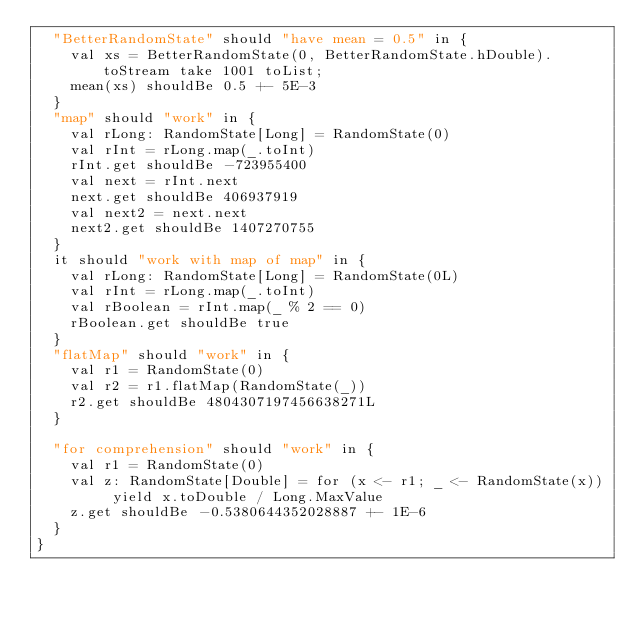Convert code to text. <code><loc_0><loc_0><loc_500><loc_500><_Scala_>  "BetterRandomState" should "have mean = 0.5" in {
    val xs = BetterRandomState(0, BetterRandomState.hDouble).toStream take 1001 toList;
    mean(xs) shouldBe 0.5 +- 5E-3
  }
  "map" should "work" in {
    val rLong: RandomState[Long] = RandomState(0)
    val rInt = rLong.map(_.toInt)
    rInt.get shouldBe -723955400
    val next = rInt.next
    next.get shouldBe 406937919
    val next2 = next.next
    next2.get shouldBe 1407270755
  }
  it should "work with map of map" in {
    val rLong: RandomState[Long] = RandomState(0L)
    val rInt = rLong.map(_.toInt)
    val rBoolean = rInt.map(_ % 2 == 0)
    rBoolean.get shouldBe true
  }
  "flatMap" should "work" in {
    val r1 = RandomState(0)
    val r2 = r1.flatMap(RandomState(_))
    r2.get shouldBe 4804307197456638271L
  }

  "for comprehension" should "work" in {
    val r1 = RandomState(0)
    val z: RandomState[Double] = for (x <- r1; _ <- RandomState(x)) yield x.toDouble / Long.MaxValue
    z.get shouldBe -0.5380644352028887 +- 1E-6
  }
}
</code> 